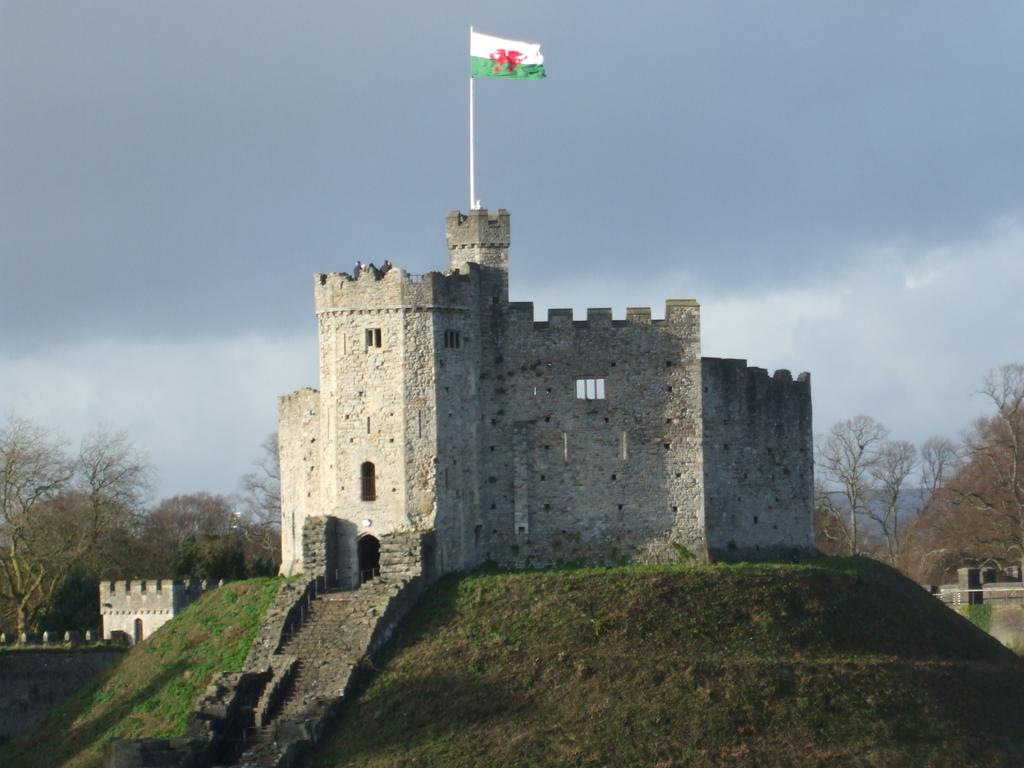What type of structure is present in the image? There is a building in the image. What color is the building? The building is gray. What can be seen flying near the building? There is a flag in the image. What colors are present on the flag? The flag has white, red, and green colors. What type of vegetation is visible in the background of the image? There are trees in the background of the image. What color are the trees? The trees are green. What is visible in the sky in the background of the image? The sky is visible in the background of the image. What color is the sky? The sky is white. What type of store is located near the trees in the image? There is no store mentioned or visible in the image. What is the desire of the trees in the image? Trees do not have desires, as they are inanimate objects. 